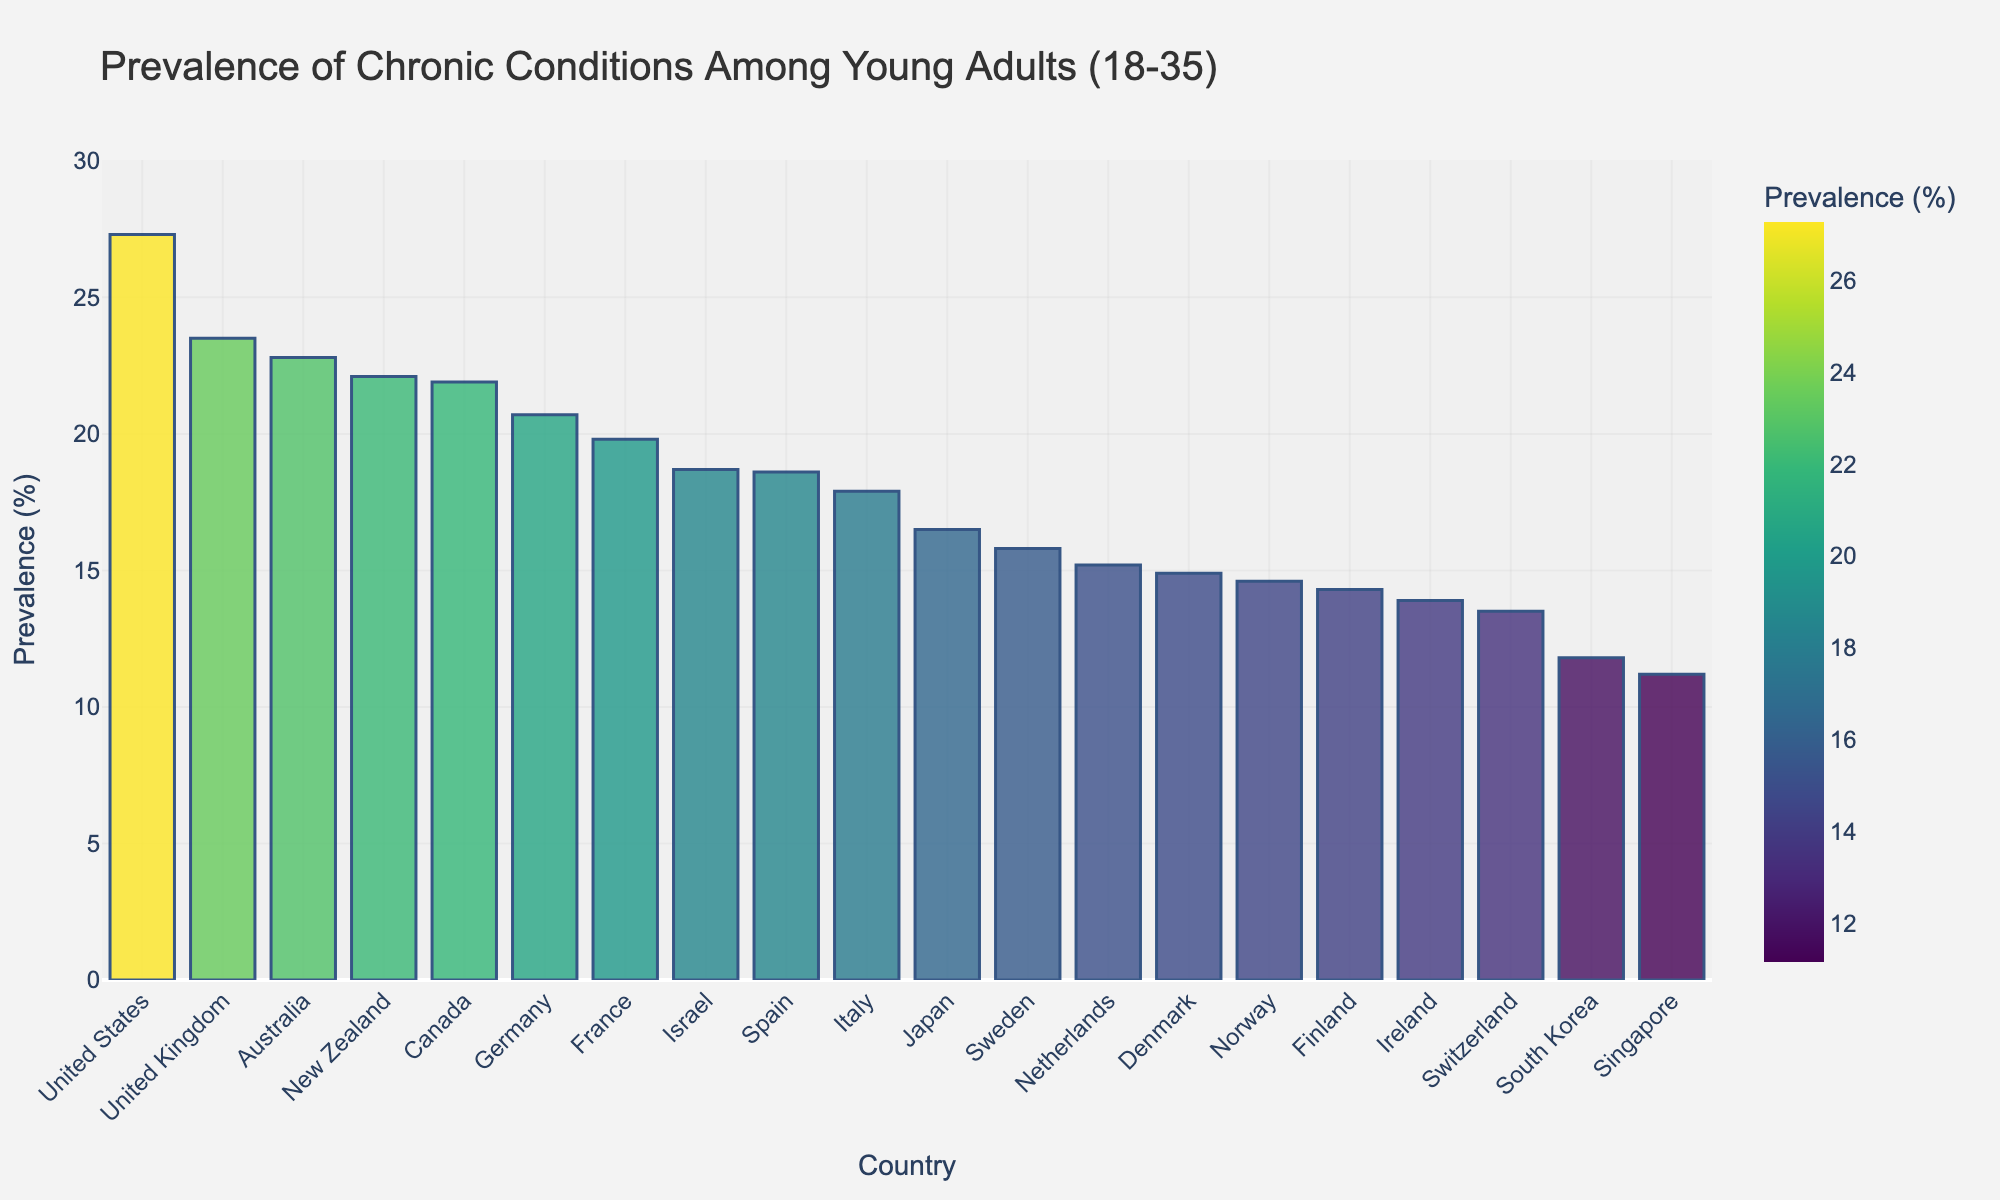What is the country with the highest prevalence of chronic conditions among young adults? Look for the tallest bar in the figure. The tallest bar represents the country with the highest prevalence of chronic conditions. In this figure, it is the United States.
Answer: United States Which two countries have the closest prevalence rates? Identify the bars with heights that are close to each other. Compare the values. In this case, Australia (22.8%) and New Zealand (22.1%) have very close prevalence rates.
Answer: Australia and New Zealand What is the prevalence difference between the United States and Norway? Find the height of the bars for the United States (27.3%) and Norway (14.6%). Calculate the difference: 27.3% - 14.6% = 12.7%.
Answer: 12.7% What is the average prevalence rate of chronic conditions in the top 3 countries? Identify the top 3 countries with the highest rates: United States (27.3%), United Kingdom (23.5%), and Australia (22.8%). Calculate the average: (27.3 + 23.5 + 22.8) / 3 = 24.53%.
Answer: 24.53% Are there more countries with a prevalence rate above or below 20%? Count the number of bars above and below the 20% mark. There are 8 countries above 20% and 12 countries below 20%.
Answer: Below 20% What is the median prevalence rate for all the countries shown? Sort all prevalence rates and find the middle value. With 20 countries, the median is the average of the 10th and 11th values: (16.5% + 17.9%) / 2 = 17.2%.
Answer: 17.2% Which country has the lowest prevalence of chronic conditions among young adults? Look for the shortest bar in the figure. The shortest bar represents the country with the lowest prevalence of chronic conditions, which is Singapore (11.2%).
Answer: Singapore Which country has a higher prevalence rate, Israel or Spain? Compare the height of the bars for Israel (18.7%) and Spain (18.6%). Israel has a slightly higher prevalence rate.
Answer: Israel What is the total prevalence rate for the United States, United Kingdom, and Canada combined? Sum the prevalence rates of these three countries: 27.3% (United States) + 23.5% (United Kingdom) + 21.9% (Canada) = 72.7%.
Answer: 72.7% How does the prevalence rate in France compare to that in Italy? Look at the height of the bars for France (19.8%) and Italy (17.9%). The prevalence rate in France is higher.
Answer: France 